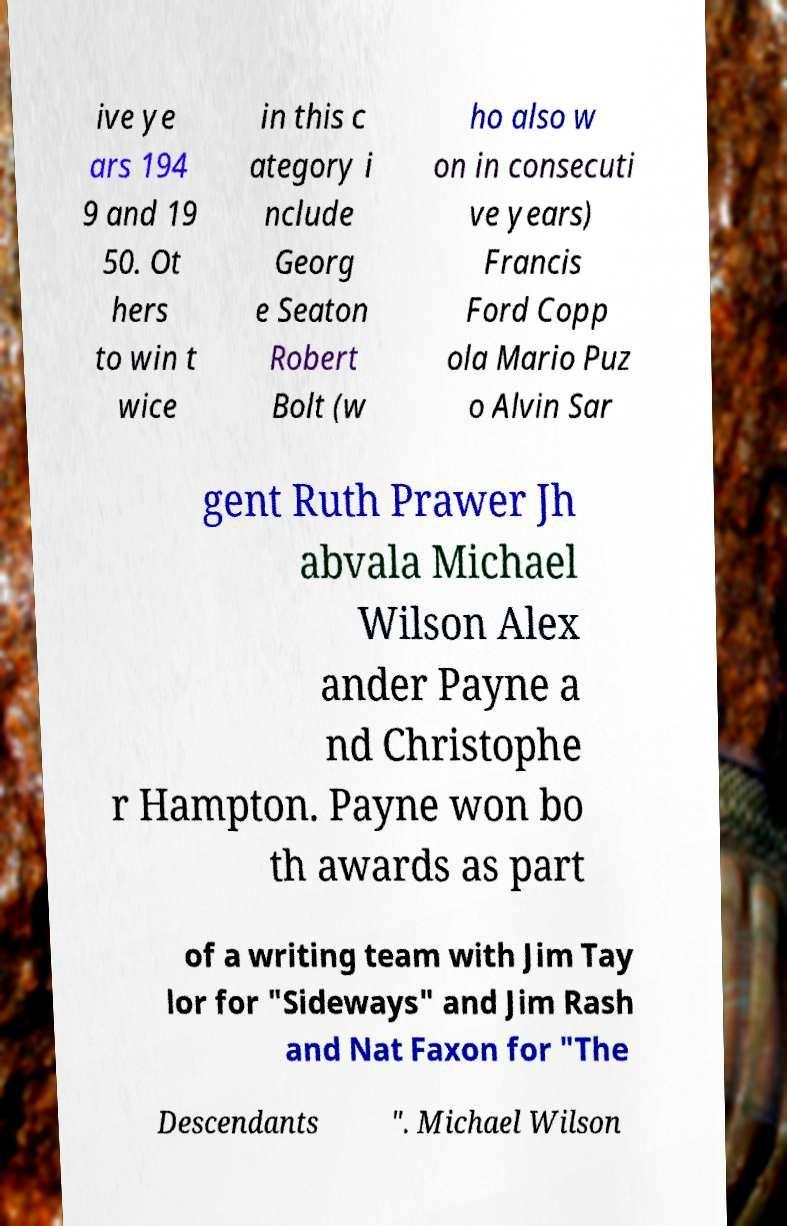Please identify and transcribe the text found in this image. ive ye ars 194 9 and 19 50. Ot hers to win t wice in this c ategory i nclude Georg e Seaton Robert Bolt (w ho also w on in consecuti ve years) Francis Ford Copp ola Mario Puz o Alvin Sar gent Ruth Prawer Jh abvala Michael Wilson Alex ander Payne a nd Christophe r Hampton. Payne won bo th awards as part of a writing team with Jim Tay lor for "Sideways" and Jim Rash and Nat Faxon for "The Descendants ". Michael Wilson 